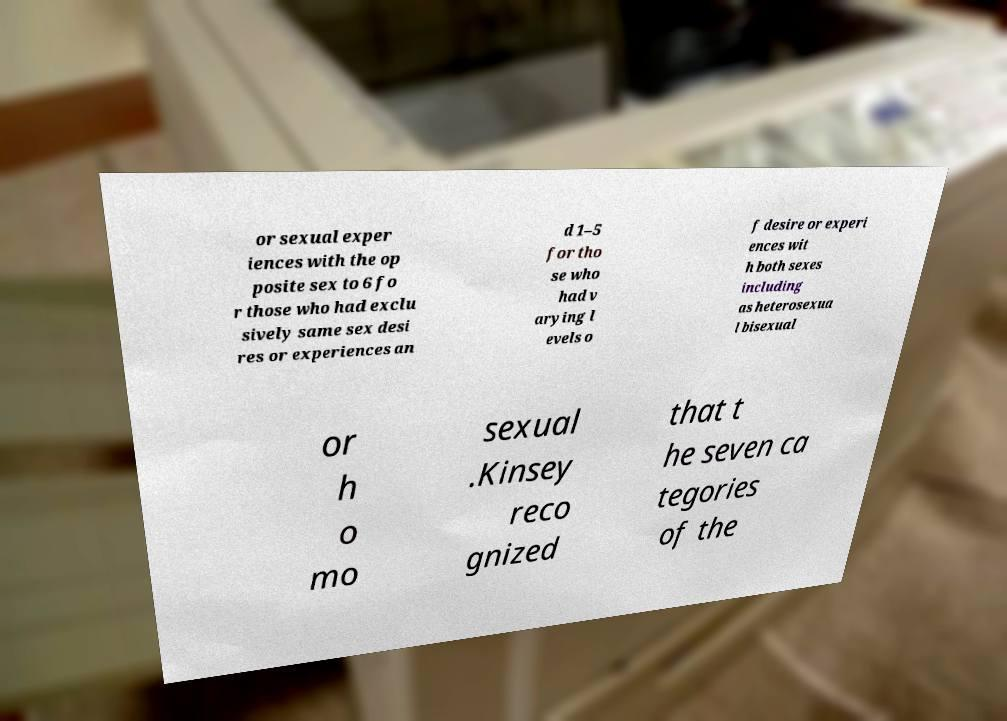Could you assist in decoding the text presented in this image and type it out clearly? or sexual exper iences with the op posite sex to 6 fo r those who had exclu sively same sex desi res or experiences an d 1–5 for tho se who had v arying l evels o f desire or experi ences wit h both sexes including as heterosexua l bisexual or h o mo sexual .Kinsey reco gnized that t he seven ca tegories of the 